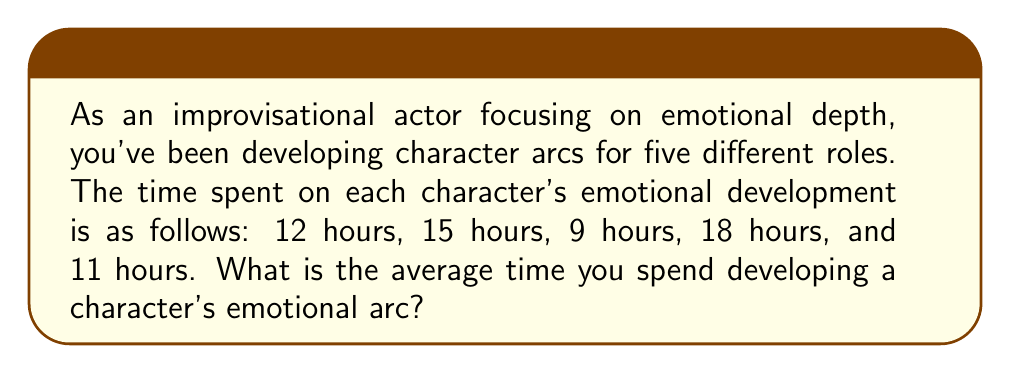Can you solve this math problem? To find the average time spent developing a character's emotional arc, we need to follow these steps:

1. Sum up all the times spent on each character:
   $12 + 15 + 9 + 18 + 11 = 65$ hours

2. Count the total number of characters:
   There are 5 characters in total.

3. Calculate the average by dividing the sum by the number of characters:
   $\text{Average} = \frac{\text{Sum of all times}}{\text{Number of characters}}$

   $\text{Average} = \frac{65}{5} = 13$ hours

Therefore, the average time spent developing a character's emotional arc is 13 hours.
Answer: $13$ hours 